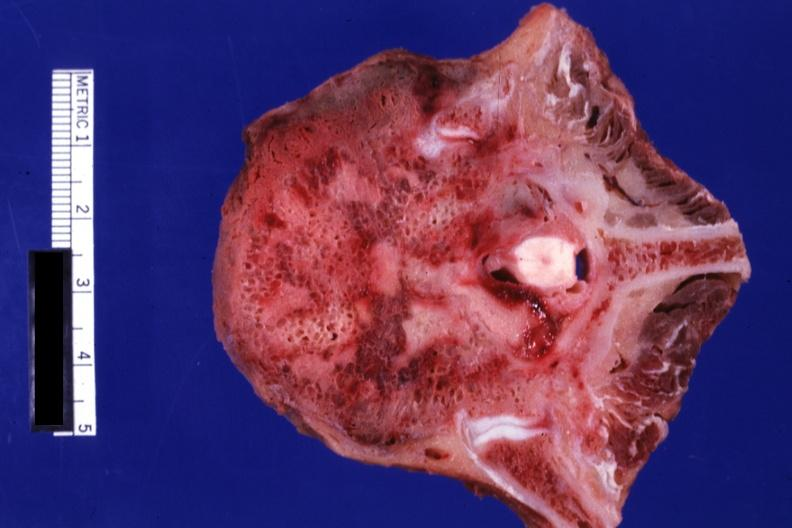does this image show close-up view excellent primary in mediastinum?
Answer the question using a single word or phrase. Yes 